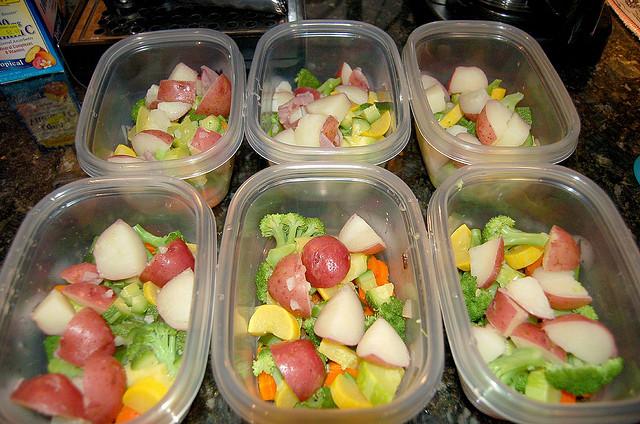Are all the containers holding the identical salad?
Concise answer only. Yes. How many containers are in the photo?
Keep it brief. 6. Are these foods being packed to eat later?
Short answer required. Yes. 